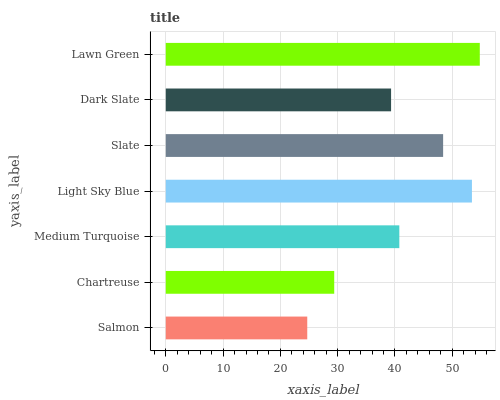Is Salmon the minimum?
Answer yes or no. Yes. Is Lawn Green the maximum?
Answer yes or no. Yes. Is Chartreuse the minimum?
Answer yes or no. No. Is Chartreuse the maximum?
Answer yes or no. No. Is Chartreuse greater than Salmon?
Answer yes or no. Yes. Is Salmon less than Chartreuse?
Answer yes or no. Yes. Is Salmon greater than Chartreuse?
Answer yes or no. No. Is Chartreuse less than Salmon?
Answer yes or no. No. Is Medium Turquoise the high median?
Answer yes or no. Yes. Is Medium Turquoise the low median?
Answer yes or no. Yes. Is Chartreuse the high median?
Answer yes or no. No. Is Light Sky Blue the low median?
Answer yes or no. No. 